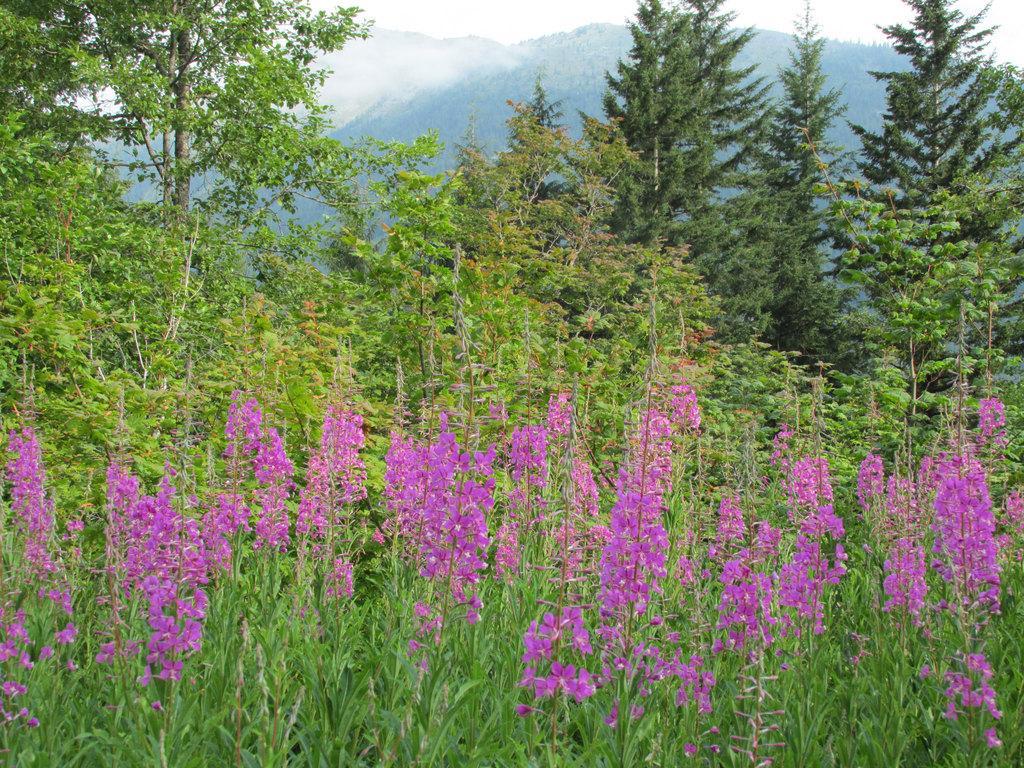Can you describe this image briefly? In this image there are some plants and some flowers, and in the background there are mountains and some trees and fog. 